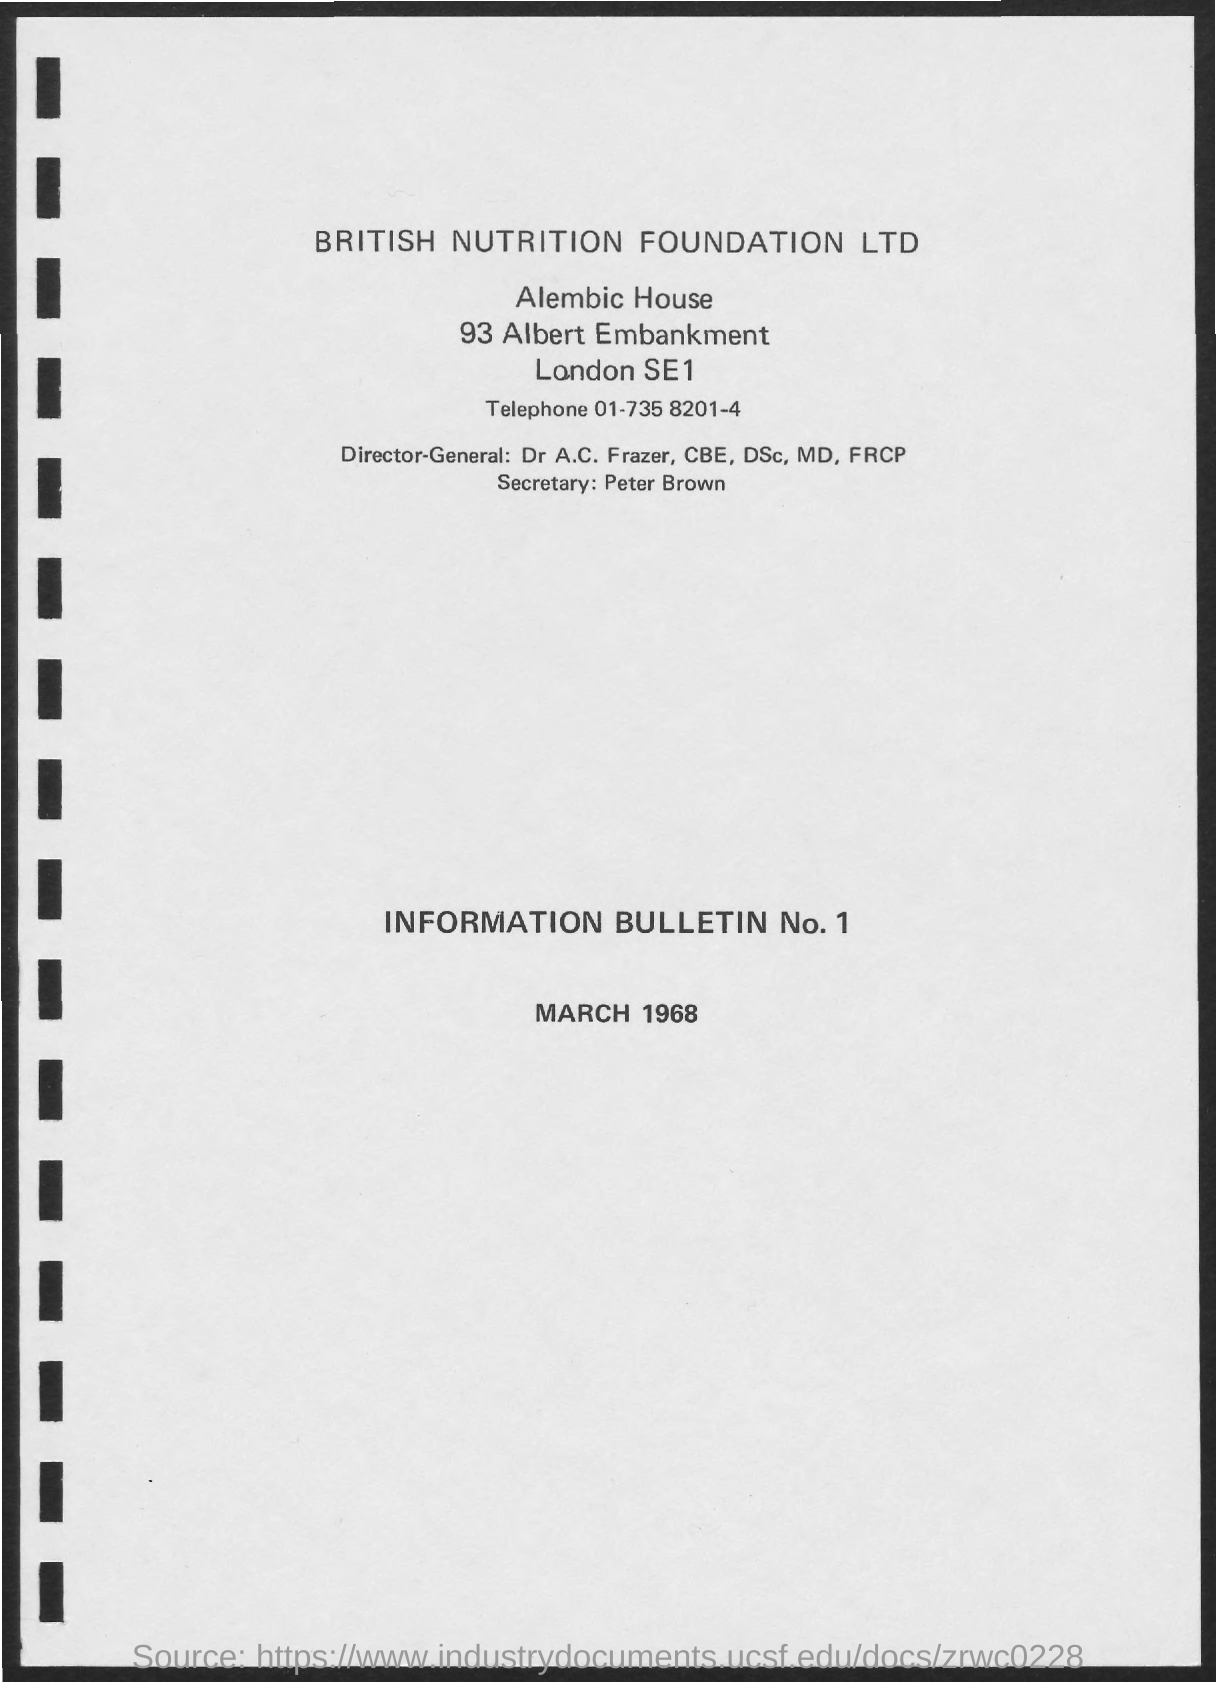Point out several critical features in this image. The Director-General of British Nutrition Foundation Ltd is Dr. A.C. Frazer, who holds the titles of CBE, Dsc, MD, and FRCP. The Secretary of the British Nutrition Foundation Ltd. is Peter Brown. 